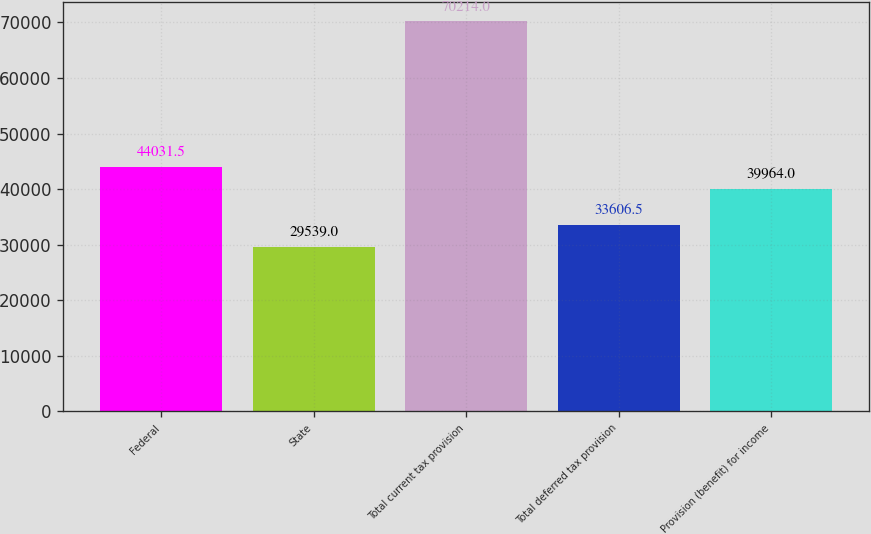Convert chart to OTSL. <chart><loc_0><loc_0><loc_500><loc_500><bar_chart><fcel>Federal<fcel>State<fcel>Total current tax provision<fcel>Total deferred tax provision<fcel>Provision (benefit) for income<nl><fcel>44031.5<fcel>29539<fcel>70214<fcel>33606.5<fcel>39964<nl></chart> 